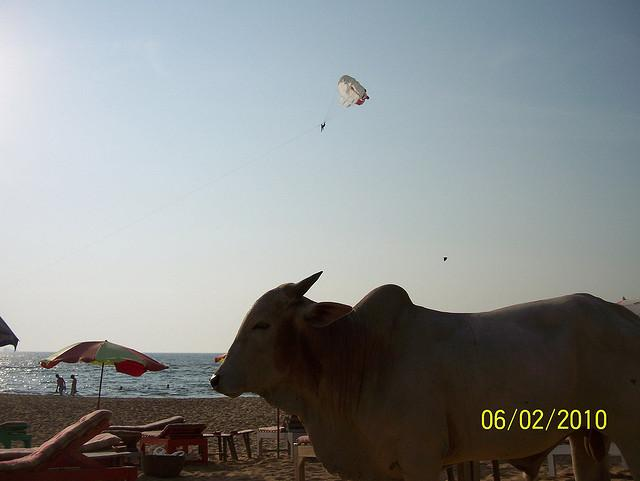What country is this beach located in?

Choices:
A) united states
B) canada
C) mexico
D) india india 